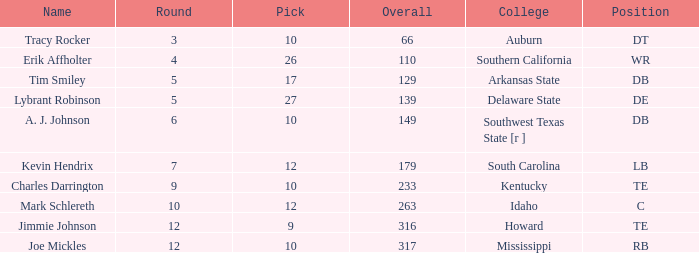What is the sum of Overall, when Name is "Tim Smiley", and when Round is less than 5? None. Parse the table in full. {'header': ['Name', 'Round', 'Pick', 'Overall', 'College', 'Position'], 'rows': [['Tracy Rocker', '3', '10', '66', 'Auburn', 'DT'], ['Erik Affholter', '4', '26', '110', 'Southern California', 'WR'], ['Tim Smiley', '5', '17', '129', 'Arkansas State', 'DB'], ['Lybrant Robinson', '5', '27', '139', 'Delaware State', 'DE'], ['A. J. Johnson', '6', '10', '149', 'Southwest Texas State [r ]', 'DB'], ['Kevin Hendrix', '7', '12', '179', 'South Carolina', 'LB'], ['Charles Darrington', '9', '10', '233', 'Kentucky', 'TE'], ['Mark Schlereth', '10', '12', '263', 'Idaho', 'C'], ['Jimmie Johnson', '12', '9', '316', 'Howard', 'TE'], ['Joe Mickles', '12', '10', '317', 'Mississippi', 'RB']]} 